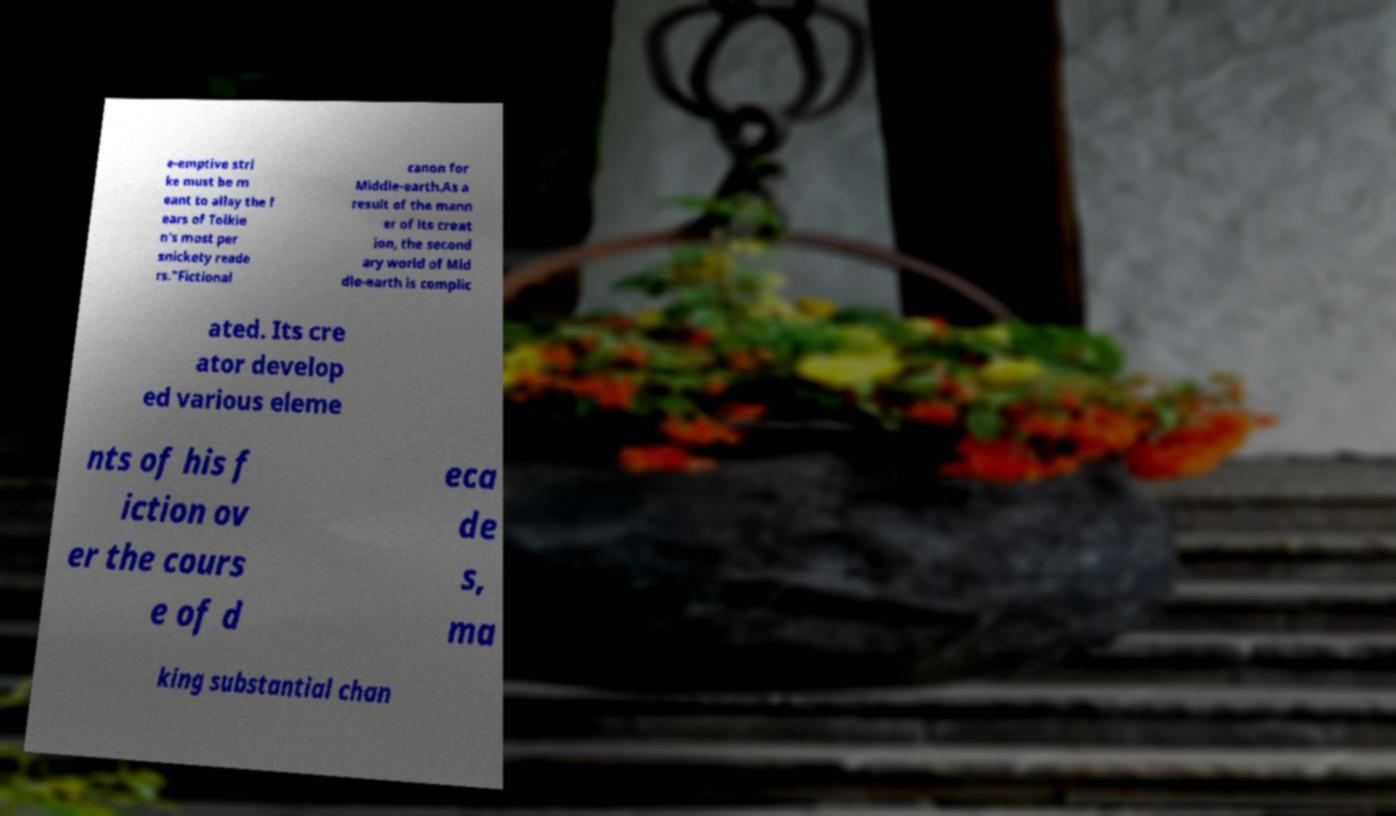Could you extract and type out the text from this image? e-emptive stri ke must be m eant to allay the f ears of Tolkie n's most per snickety reade rs."Fictional canon for Middle-earth.As a result of the mann er of its creat ion, the second ary world of Mid dle-earth is complic ated. Its cre ator develop ed various eleme nts of his f iction ov er the cours e of d eca de s, ma king substantial chan 